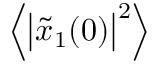<formula> <loc_0><loc_0><loc_500><loc_500>\left \langle \left | \tilde { x } _ { 1 } ( 0 ) \right | ^ { 2 } \right \rangle</formula> 